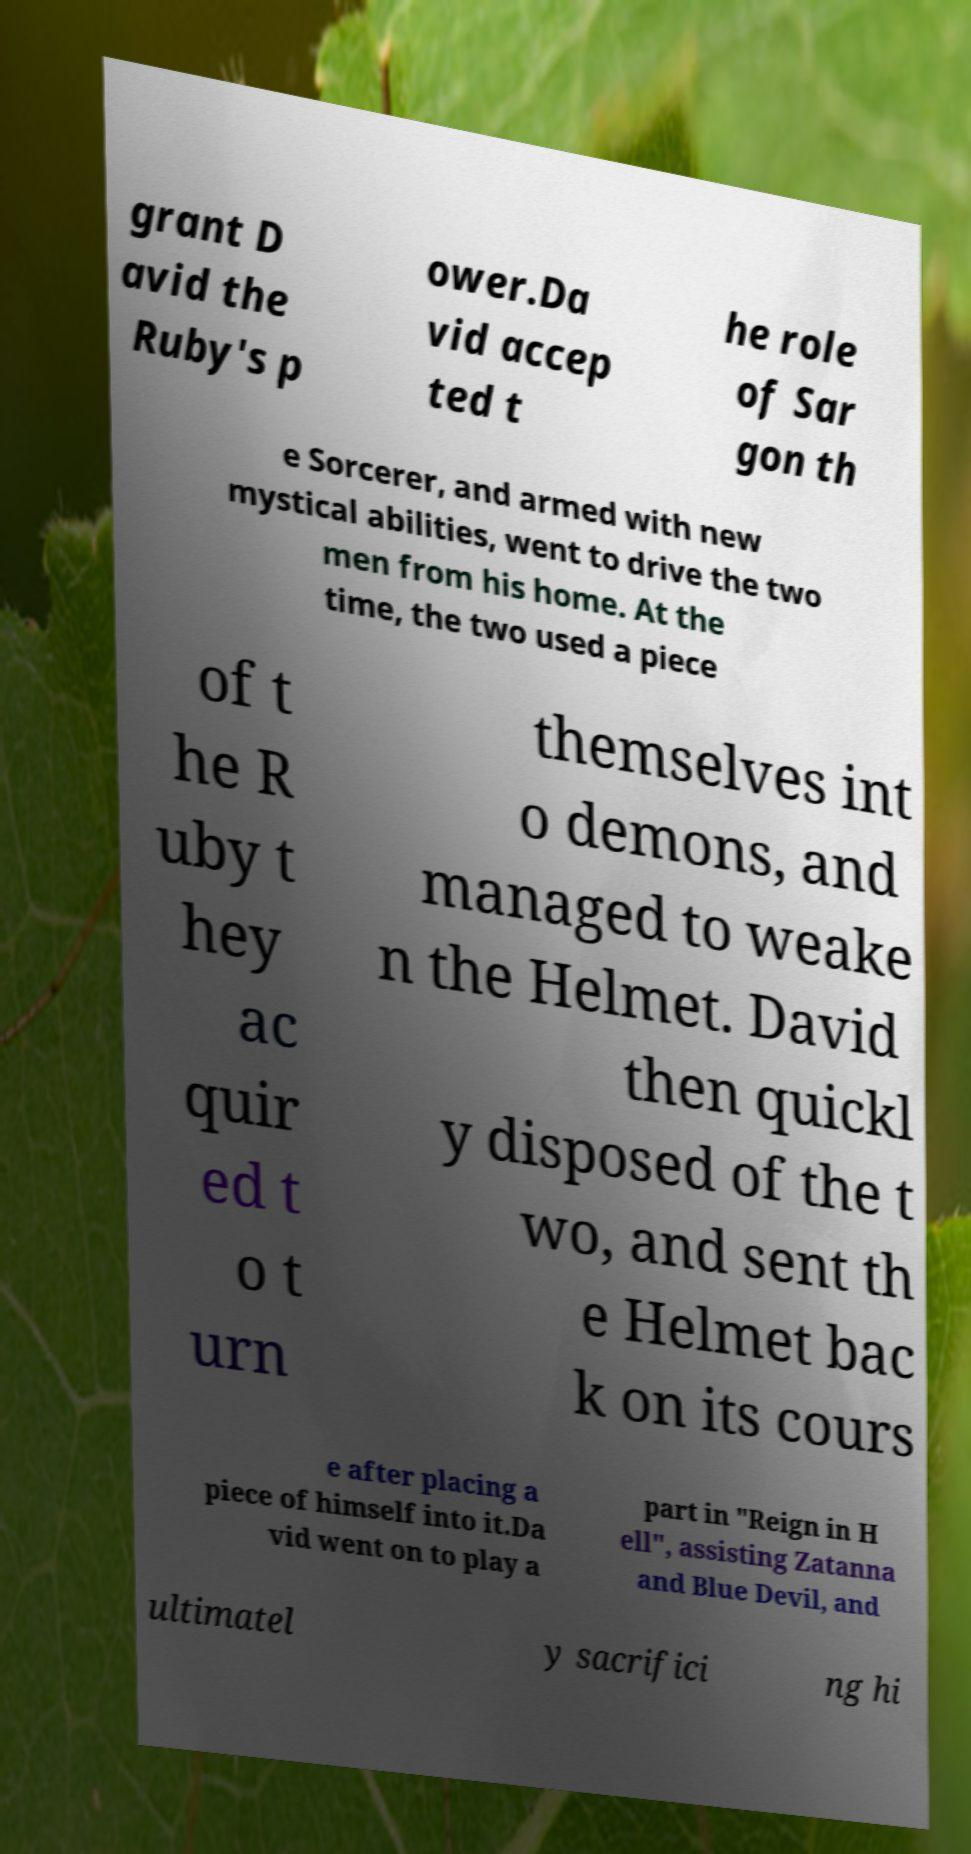Please read and relay the text visible in this image. What does it say? grant D avid the Ruby's p ower.Da vid accep ted t he role of Sar gon th e Sorcerer, and armed with new mystical abilities, went to drive the two men from his home. At the time, the two used a piece of t he R uby t hey ac quir ed t o t urn themselves int o demons, and managed to weake n the Helmet. David then quickl y disposed of the t wo, and sent th e Helmet bac k on its cours e after placing a piece of himself into it.Da vid went on to play a part in "Reign in H ell", assisting Zatanna and Blue Devil, and ultimatel y sacrifici ng hi 